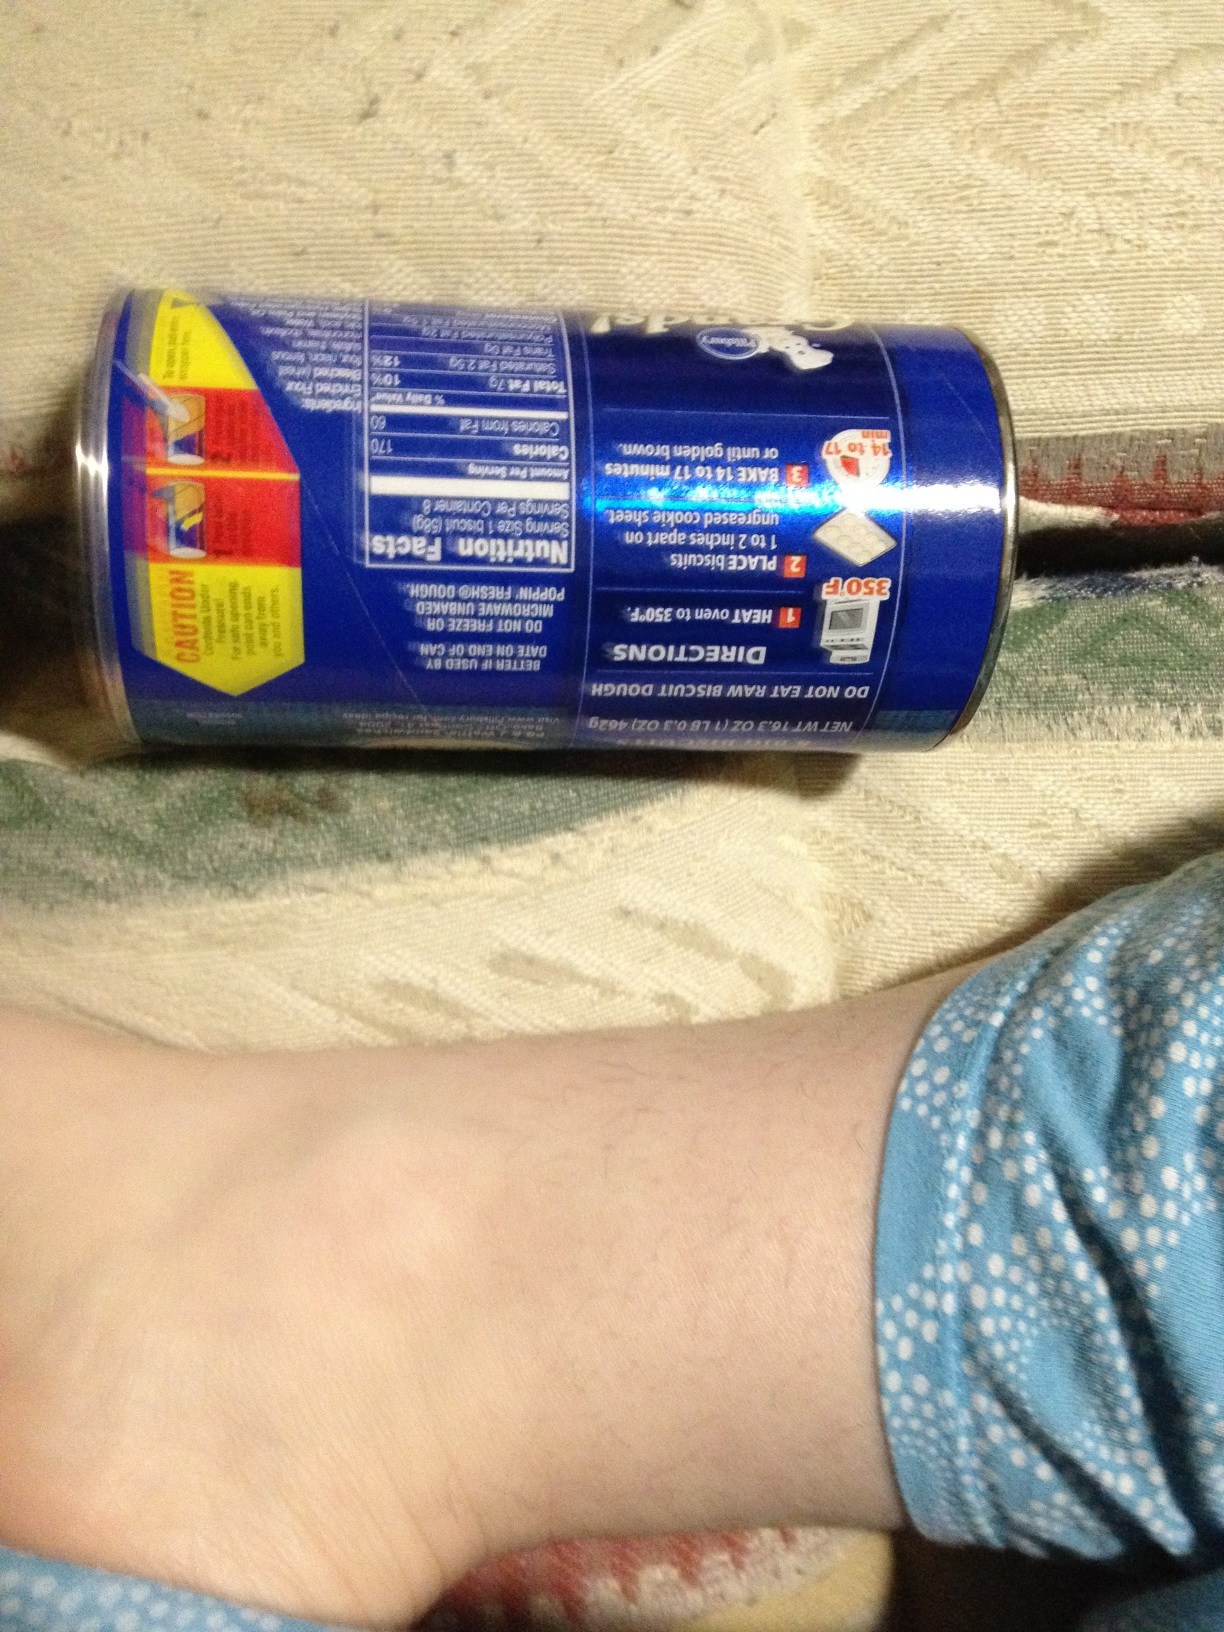What could happen if someone disregards the dietary precaution and eats the raw dough? Eating raw biscuit dough can be risky as it may contain harmful bacteria like E. coli or Salmonella, which can cause food poisoning. Symptoms include stomach cramps, diarrhea, and vomiting. It is always best to follow the instructions and bake the dough properly before consumption. 